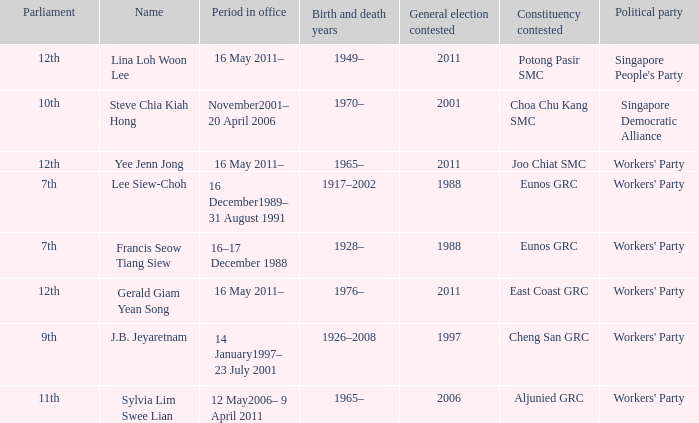What parliament's name is lina loh woon lee? 12th. 